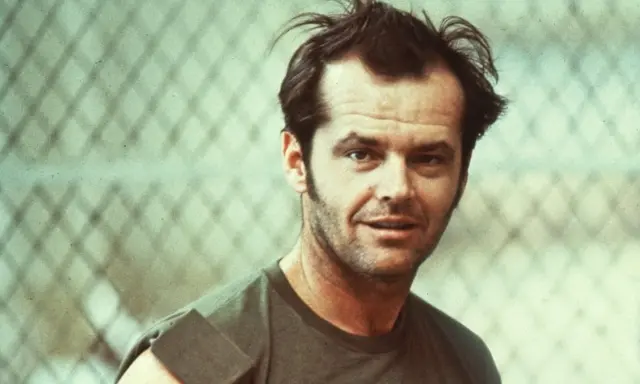Imagine this scene is from a movie. What kind of movie plot would fit this image? In a movie context, this scene could fit into a drama or a coming-of-age film. The character might be a young man facing a pivotal moment in his life, possibly struggling with personal issues or societal expectations. The chain-link fence could symbolize obstacles or boundaries he needs to overcome. The plot could revolve around his journey of self-discovery, personal growth, or rebellion against conformity. The setting hints at a gritty, realistic backdrop, exploring themes of identity, freedom, and resilience. Let's get even more imaginative - what if this image is from a fantasy world? What kind of story would unfold? In a fantasy world, the chain-link fence could be enchanted, holding back a realm of mystical creatures or forbidden lands. The young man might be a guardian or a reluctant hero discovering his magical abilities. He could be pondering a quest he must undertake to restore balance to both worlds, confronting mythical beings and uncovering ancient secrets. The plot might weave themes of destiny, courage, and the struggle between good and evil, with the fence acting as a gateway to untold adventures and mysteries. 